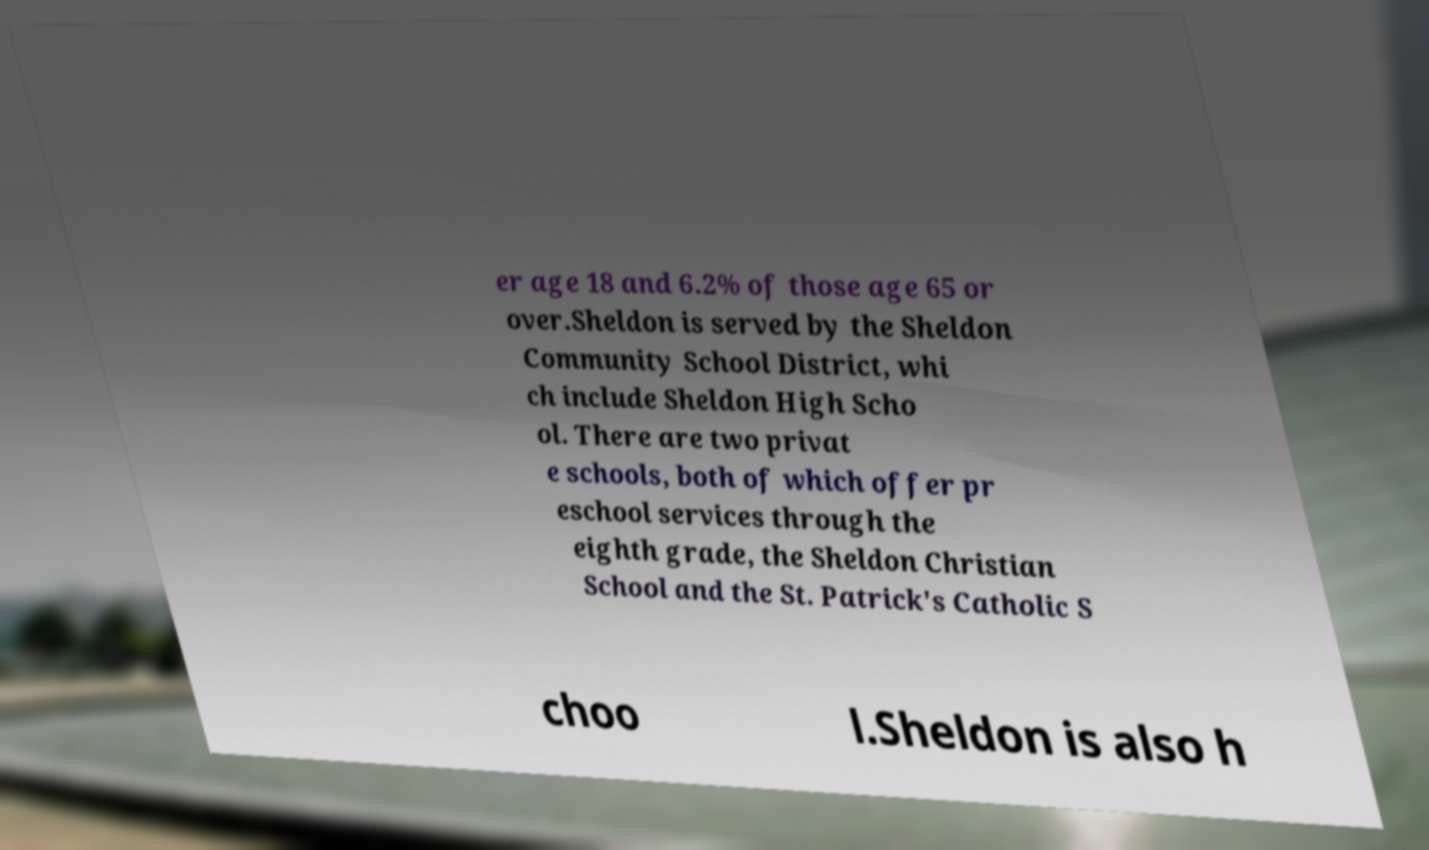Please read and relay the text visible in this image. What does it say? er age 18 and 6.2% of those age 65 or over.Sheldon is served by the Sheldon Community School District, whi ch include Sheldon High Scho ol. There are two privat e schools, both of which offer pr eschool services through the eighth grade, the Sheldon Christian School and the St. Patrick's Catholic S choo l.Sheldon is also h 